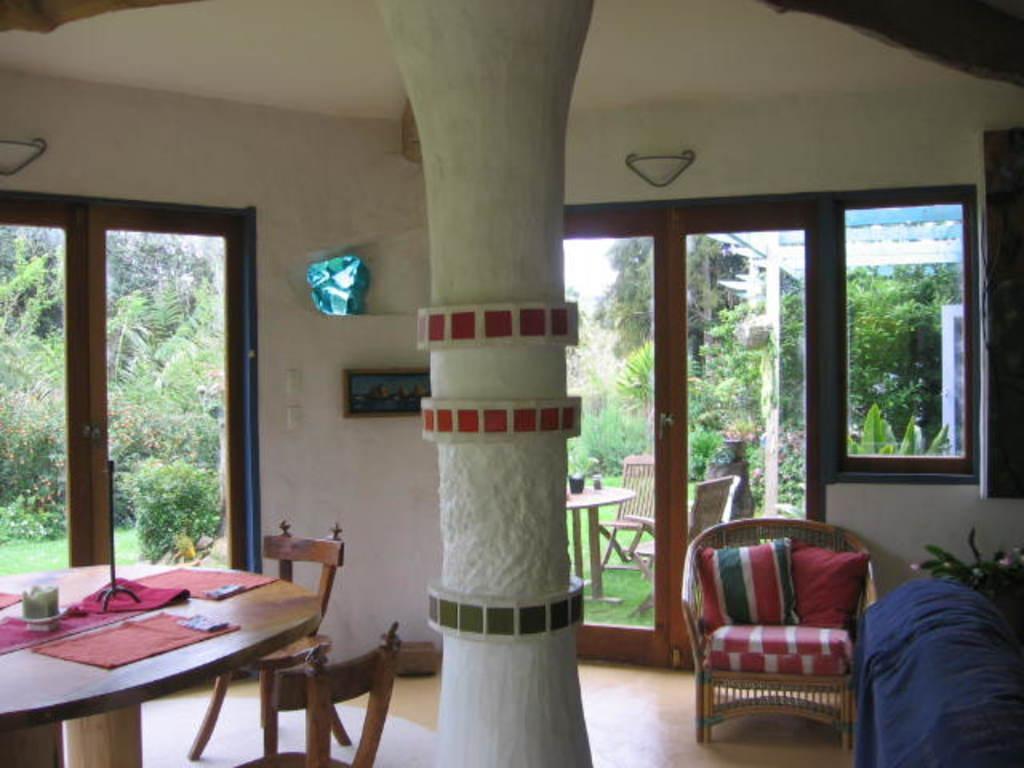How would you summarize this image in a sentence or two? In this image we can see the inner view of a room. In the room there are table, napkins, chairs, houseplant, pillars, cushions and a photo frame attached to the wall. In the background we can see chairs, table, ground, bushes, trees and sky. 